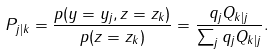Convert formula to latex. <formula><loc_0><loc_0><loc_500><loc_500>P _ { j | k } = \frac { p ( y = y _ { j } , z = z _ { k } ) } { p ( z = z _ { k } ) } = \frac { q _ { j } Q _ { k | j } } { \sum _ { j } q _ { j } Q _ { k | j } } .</formula> 